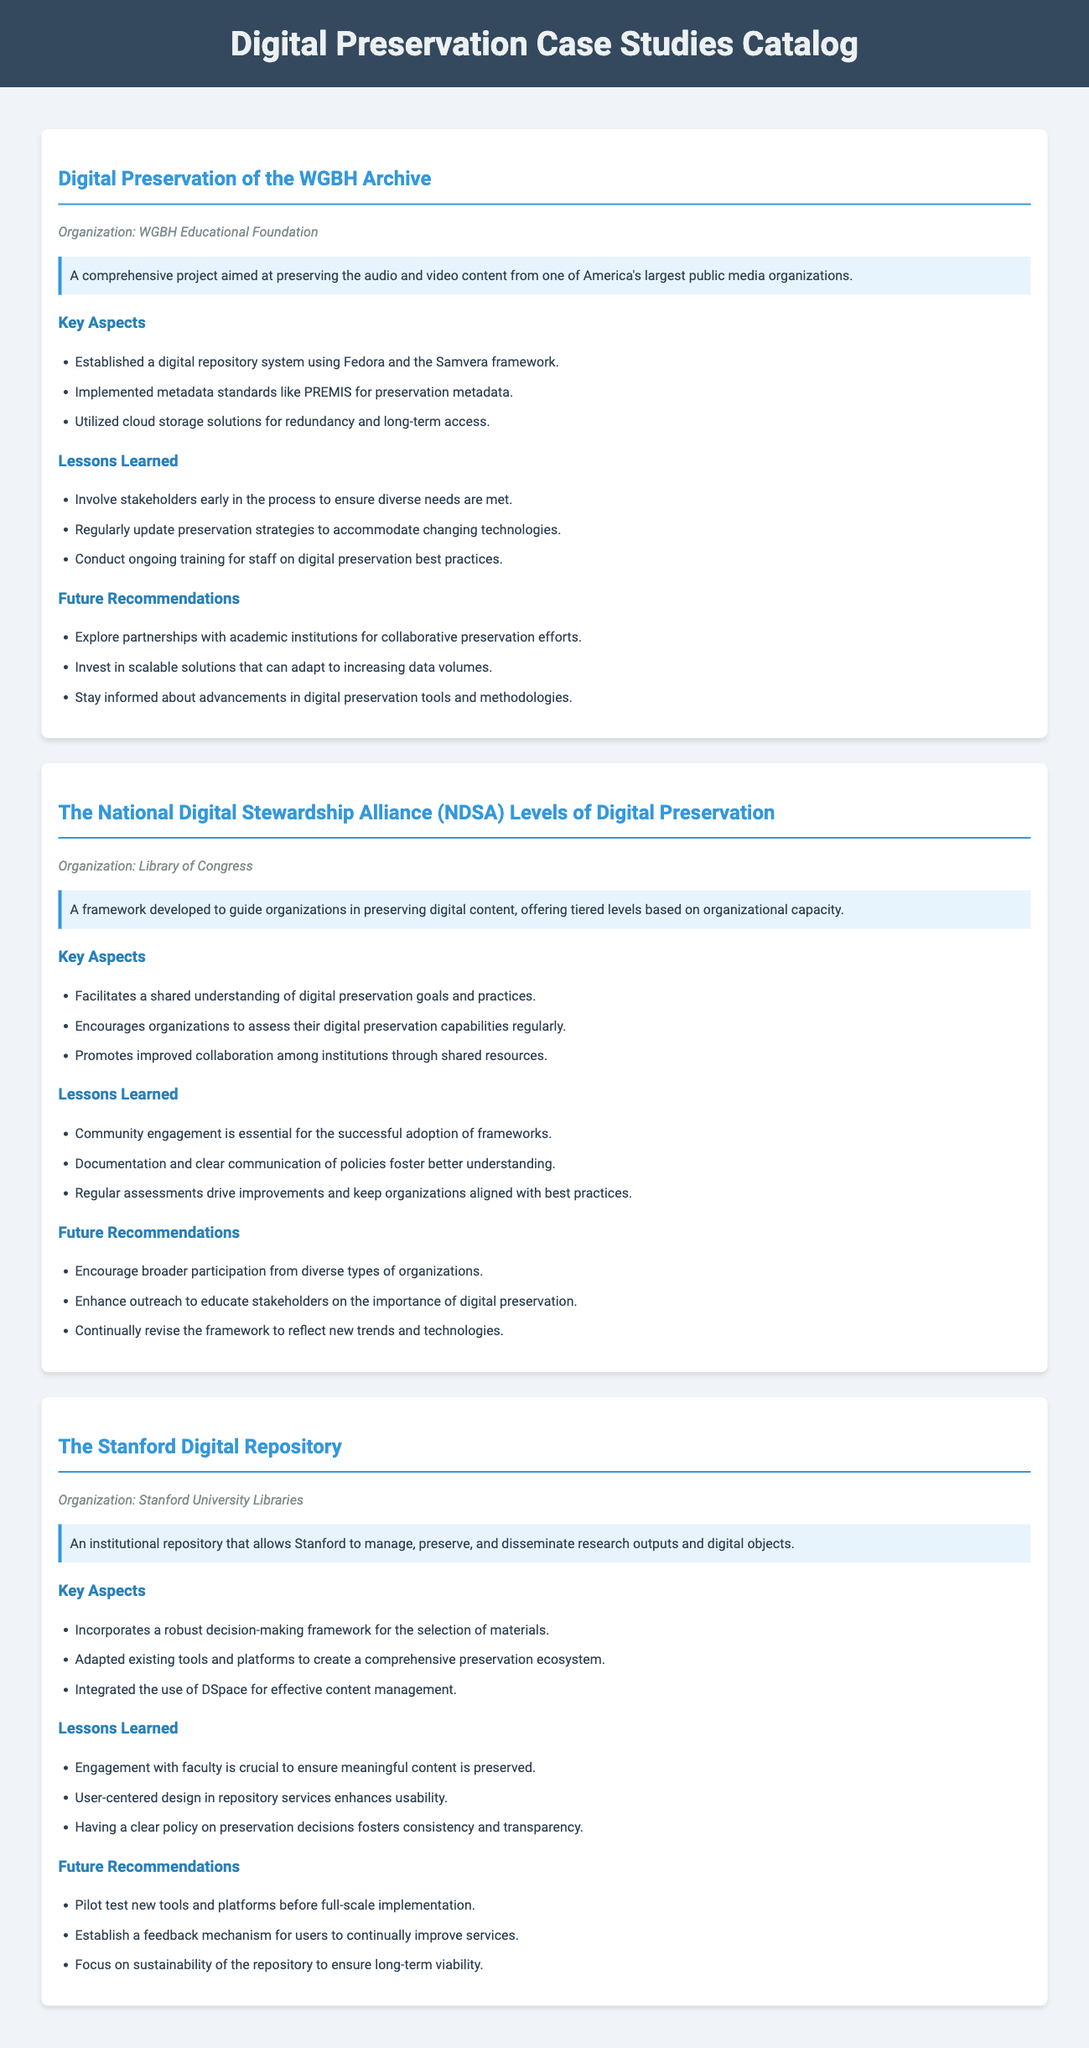What is the title of the first case study? The title of the first case study is based on the preservation of the WGBH Archive.
Answer: Digital Preservation of the WGBH Archive Which organization is associated with the second case study? The second case study is linked to the Library of Congress, as noted in the document.
Answer: Library of Congress What metadata standards were implemented in the WGBH Archive project? The document specifically lists the use of PREMIS for preservation metadata as a key aspect of the project.
Answer: PREMIS What recommendation is made for future enhancements in the first case study? The future recommendations section of the first case study suggests exploring partnerships with academic institutions.
Answer: Explore partnerships with academic institutions How many key aspects are outlined in the Stanford Digital Repository case study? The document mentions three key aspects related to the Stanford Digital Repository, making it a straightforward retrieval.
Answer: Three What is emphasized in the lessons learned from the NDSA Levels of Digital Preservation? The lessons learned highlight the importance of community engagement for the successful adoption of frameworks.
Answer: Community engagement What tool is integrated for effective content management in the Stanford Digital Repository? The text clearly states that DSpace is integrated for effective content management.
Answer: DSpace What do the lessons learned of the WGBH Archive project suggest about staff training? One of the key lessons is that ongoing training for staff on digital preservation best practices is essential.
Answer: Ongoing training for staff Which future recommendation focuses on sustainability in the Stanford Digital Repository? The document indicates a recommendation to focus on the sustainability of the repository for long-term viability.
Answer: Focus on sustainability of the repository 